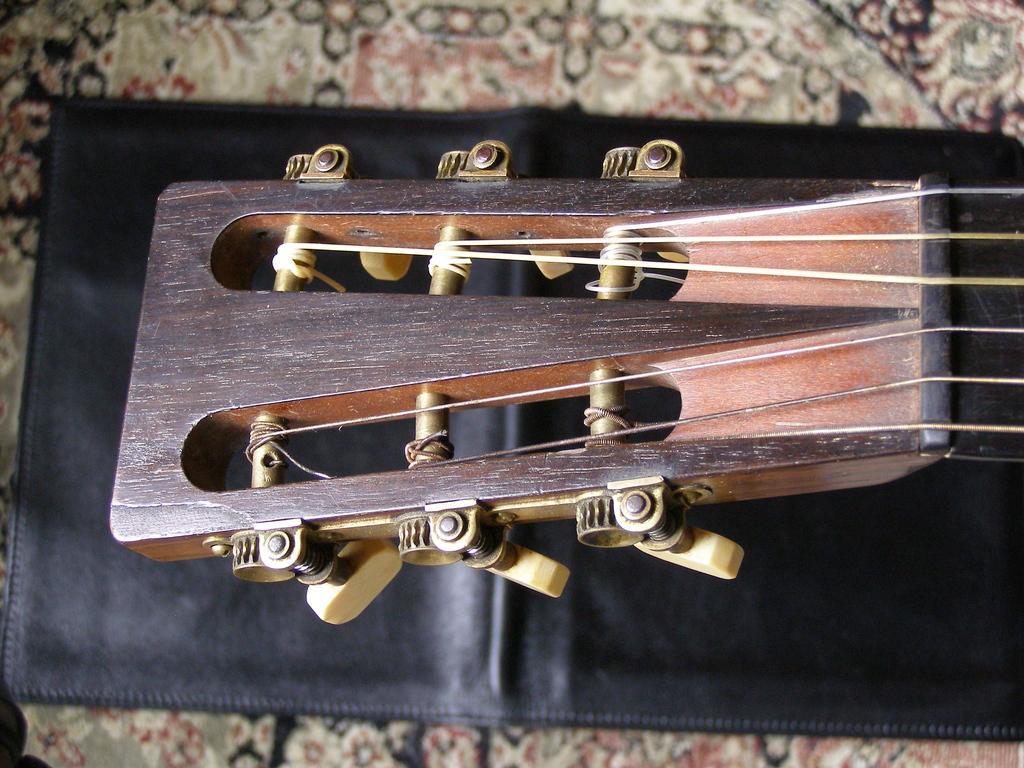Can you describe this image briefly? In this picture there is a top most part of the guitar placed on the table. 